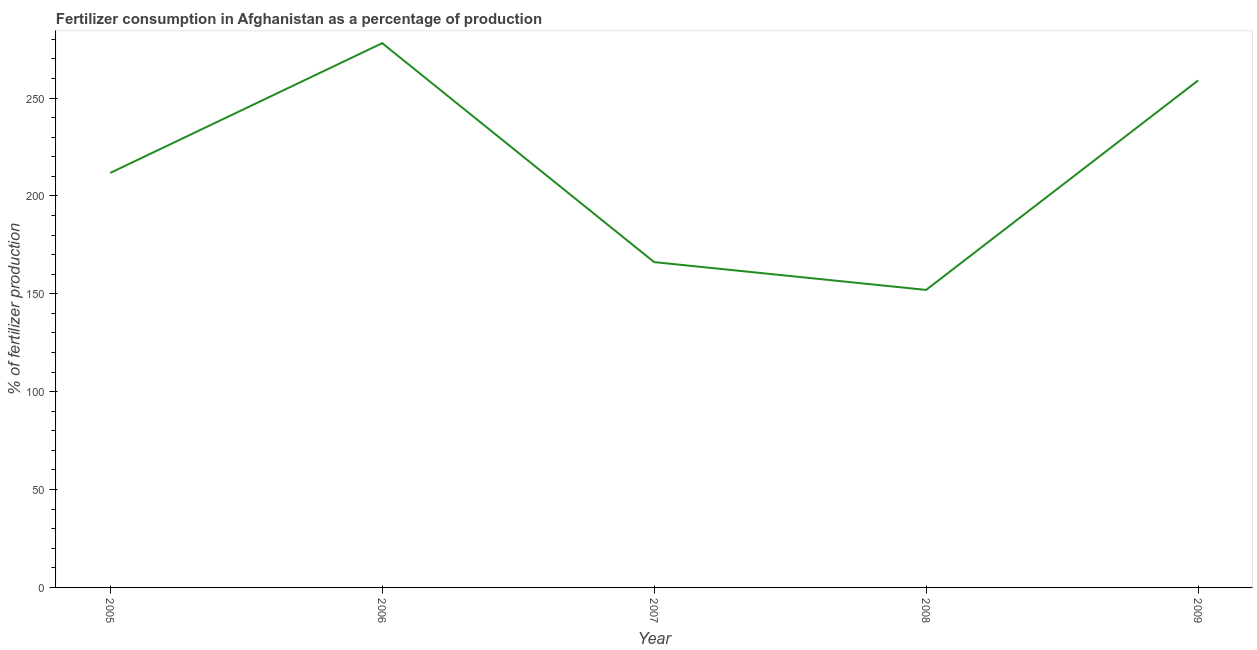What is the amount of fertilizer consumption in 2006?
Offer a very short reply. 278.02. Across all years, what is the maximum amount of fertilizer consumption?
Your answer should be very brief. 278.02. Across all years, what is the minimum amount of fertilizer consumption?
Provide a short and direct response. 151.98. In which year was the amount of fertilizer consumption minimum?
Your response must be concise. 2008. What is the sum of the amount of fertilizer consumption?
Provide a succinct answer. 1066.88. What is the difference between the amount of fertilizer consumption in 2007 and 2009?
Your response must be concise. -92.8. What is the average amount of fertilizer consumption per year?
Offer a very short reply. 213.38. What is the median amount of fertilizer consumption?
Provide a short and direct response. 211.73. In how many years, is the amount of fertilizer consumption greater than 60 %?
Your response must be concise. 5. What is the ratio of the amount of fertilizer consumption in 2006 to that in 2007?
Offer a very short reply. 1.67. Is the amount of fertilizer consumption in 2005 less than that in 2006?
Give a very brief answer. Yes. What is the difference between the highest and the second highest amount of fertilizer consumption?
Your answer should be compact. 19.05. Is the sum of the amount of fertilizer consumption in 2005 and 2006 greater than the maximum amount of fertilizer consumption across all years?
Offer a very short reply. Yes. What is the difference between the highest and the lowest amount of fertilizer consumption?
Keep it short and to the point. 126.04. Does the amount of fertilizer consumption monotonically increase over the years?
Make the answer very short. No. What is the difference between two consecutive major ticks on the Y-axis?
Offer a very short reply. 50. What is the title of the graph?
Keep it short and to the point. Fertilizer consumption in Afghanistan as a percentage of production. What is the label or title of the X-axis?
Provide a short and direct response. Year. What is the label or title of the Y-axis?
Give a very brief answer. % of fertilizer production. What is the % of fertilizer production in 2005?
Provide a succinct answer. 211.73. What is the % of fertilizer production of 2006?
Give a very brief answer. 278.02. What is the % of fertilizer production in 2007?
Make the answer very short. 166.18. What is the % of fertilizer production of 2008?
Your response must be concise. 151.98. What is the % of fertilizer production of 2009?
Make the answer very short. 258.97. What is the difference between the % of fertilizer production in 2005 and 2006?
Ensure brevity in your answer.  -66.29. What is the difference between the % of fertilizer production in 2005 and 2007?
Provide a succinct answer. 45.56. What is the difference between the % of fertilizer production in 2005 and 2008?
Keep it short and to the point. 59.76. What is the difference between the % of fertilizer production in 2005 and 2009?
Your answer should be very brief. -47.24. What is the difference between the % of fertilizer production in 2006 and 2007?
Give a very brief answer. 111.85. What is the difference between the % of fertilizer production in 2006 and 2008?
Offer a terse response. 126.04. What is the difference between the % of fertilizer production in 2006 and 2009?
Give a very brief answer. 19.05. What is the difference between the % of fertilizer production in 2007 and 2008?
Your answer should be compact. 14.2. What is the difference between the % of fertilizer production in 2007 and 2009?
Provide a succinct answer. -92.8. What is the difference between the % of fertilizer production in 2008 and 2009?
Offer a terse response. -107. What is the ratio of the % of fertilizer production in 2005 to that in 2006?
Your response must be concise. 0.76. What is the ratio of the % of fertilizer production in 2005 to that in 2007?
Your answer should be very brief. 1.27. What is the ratio of the % of fertilizer production in 2005 to that in 2008?
Your answer should be compact. 1.39. What is the ratio of the % of fertilizer production in 2005 to that in 2009?
Provide a short and direct response. 0.82. What is the ratio of the % of fertilizer production in 2006 to that in 2007?
Offer a very short reply. 1.67. What is the ratio of the % of fertilizer production in 2006 to that in 2008?
Provide a short and direct response. 1.83. What is the ratio of the % of fertilizer production in 2006 to that in 2009?
Your answer should be very brief. 1.07. What is the ratio of the % of fertilizer production in 2007 to that in 2008?
Provide a succinct answer. 1.09. What is the ratio of the % of fertilizer production in 2007 to that in 2009?
Provide a short and direct response. 0.64. What is the ratio of the % of fertilizer production in 2008 to that in 2009?
Keep it short and to the point. 0.59. 